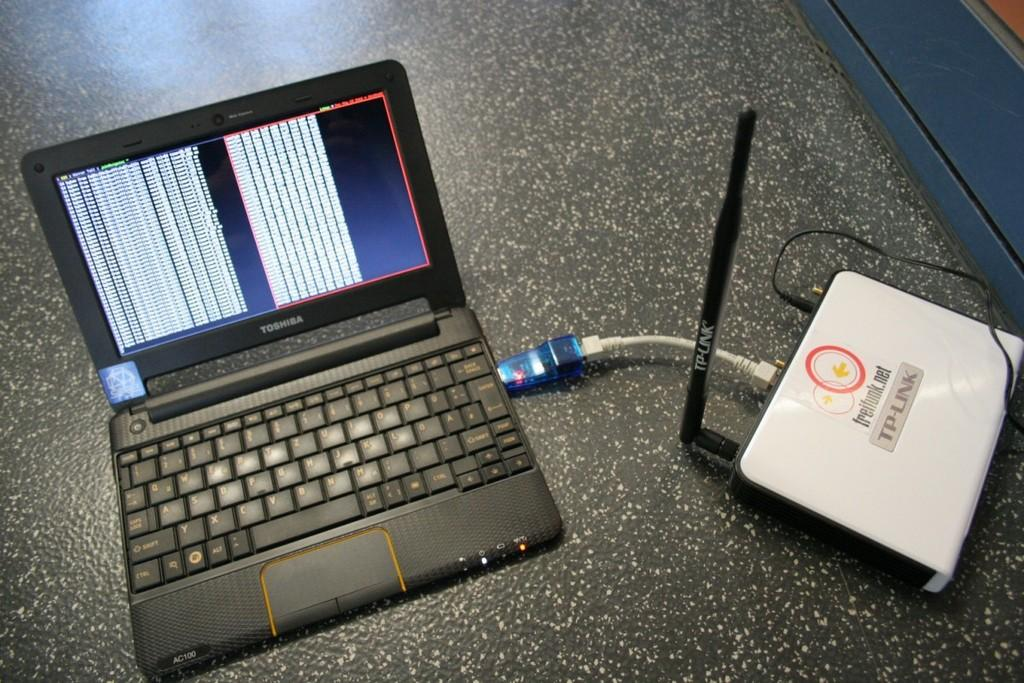<image>
Give a short and clear explanation of the subsequent image. A Toshiba laptop and a TP-Link are sitting next to each other. 